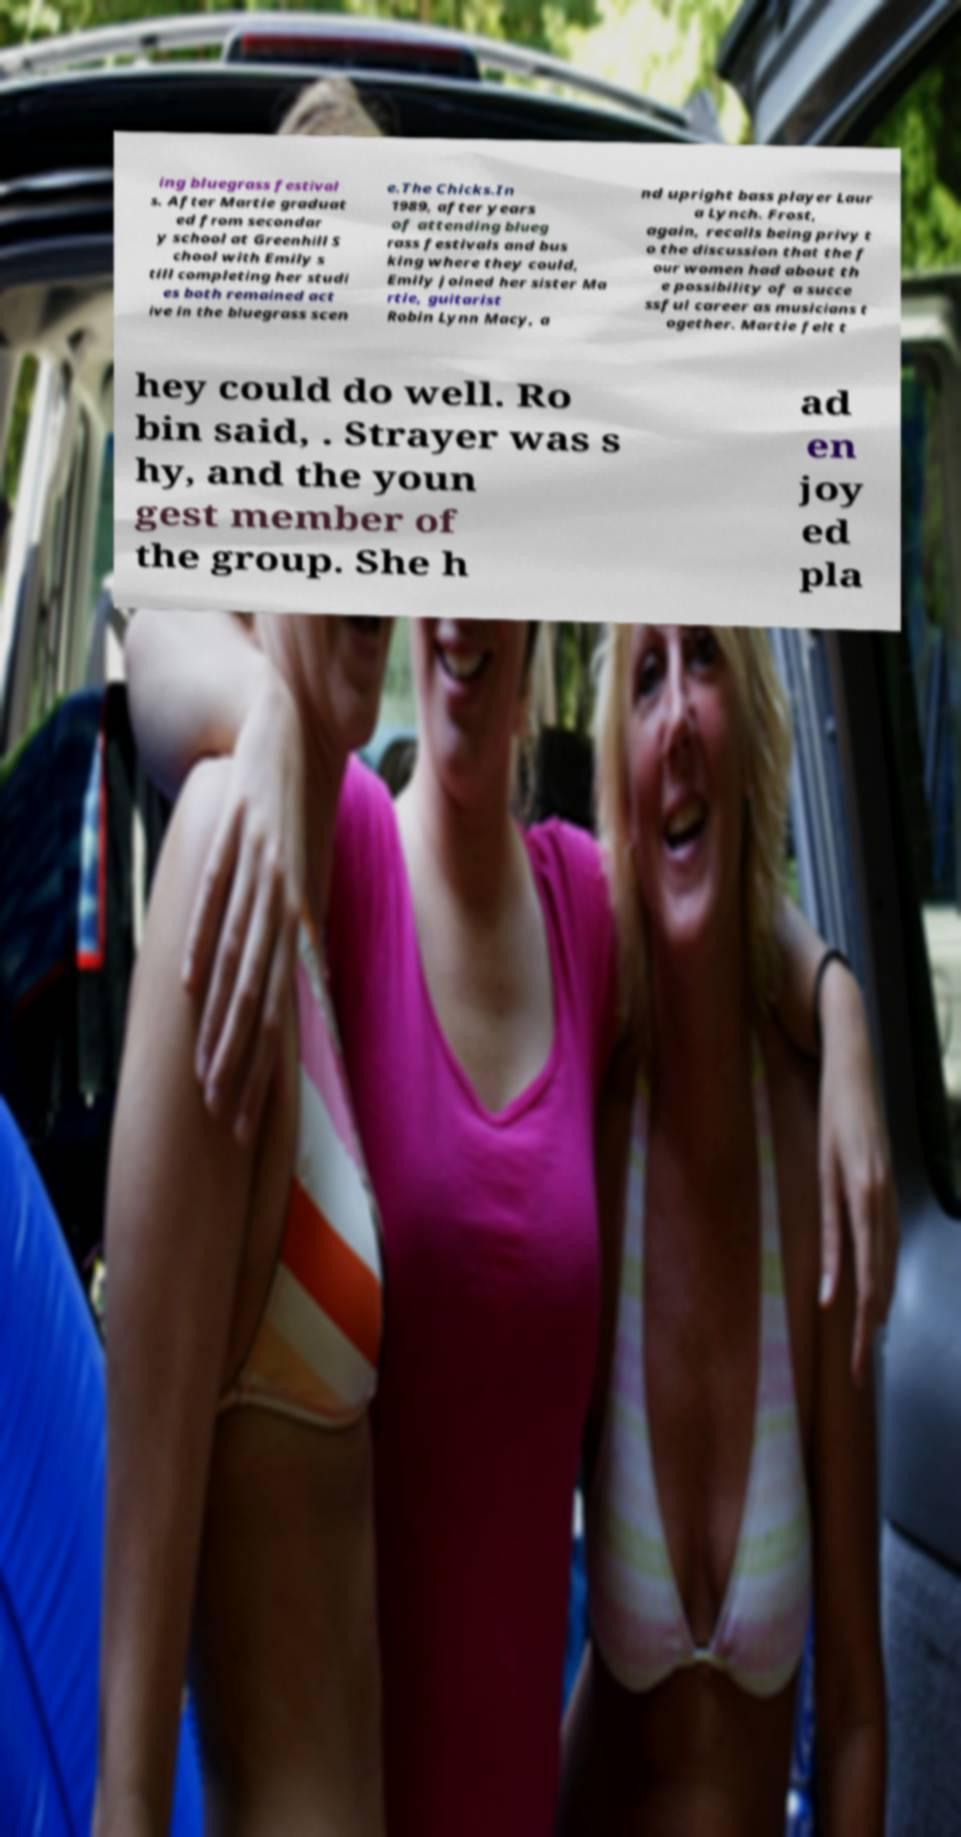Can you accurately transcribe the text from the provided image for me? ing bluegrass festival s. After Martie graduat ed from secondar y school at Greenhill S chool with Emily s till completing her studi es both remained act ive in the bluegrass scen e.The Chicks.In 1989, after years of attending blueg rass festivals and bus king where they could, Emily joined her sister Ma rtie, guitarist Robin Lynn Macy, a nd upright bass player Laur a Lynch. Frost, again, recalls being privy t o the discussion that the f our women had about th e possibility of a succe ssful career as musicians t ogether. Martie felt t hey could do well. Ro bin said, . Strayer was s hy, and the youn gest member of the group. She h ad en joy ed pla 